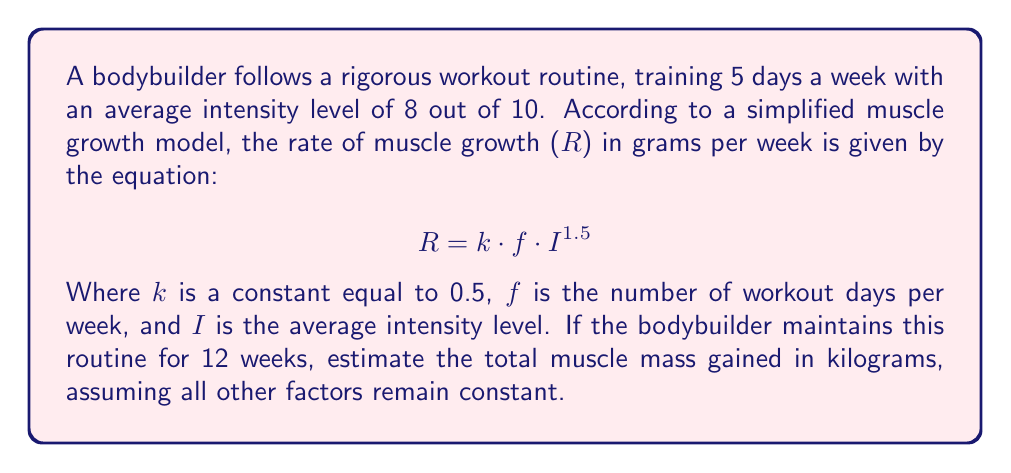Give your solution to this math problem. To solve this problem, we'll follow these steps:

1. Calculate the rate of muscle growth (R) using the given equation:
   $$ R = k \cdot f \cdot I^{1.5} $$
   $$ R = 0.5 \cdot 5 \cdot 8^{1.5} $$
   $$ R = 0.5 \cdot 5 \cdot 22.63 $$
   $$ R = 56.57 \text{ grams per week} $$

2. Calculate the total muscle mass gained over 12 weeks:
   $$ \text{Total mass} = R \cdot 12 \text{ weeks} $$
   $$ \text{Total mass} = 56.57 \cdot 12 = 678.84 \text{ grams} $$

3. Convert the result from grams to kilograms:
   $$ \text{Mass in kg} = \frac{678.84 \text{ grams}}{1000 \text{ grams/kg}} = 0.67884 \text{ kg} $$

Therefore, the estimated total muscle mass gained over 12 weeks is approximately 0.68 kg.
Answer: 0.68 kg 